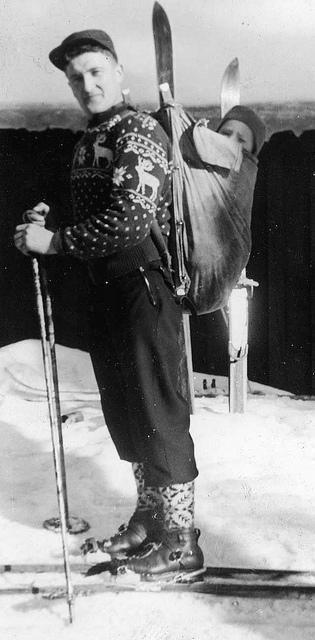How many ski are in the photo?
Give a very brief answer. 3. 